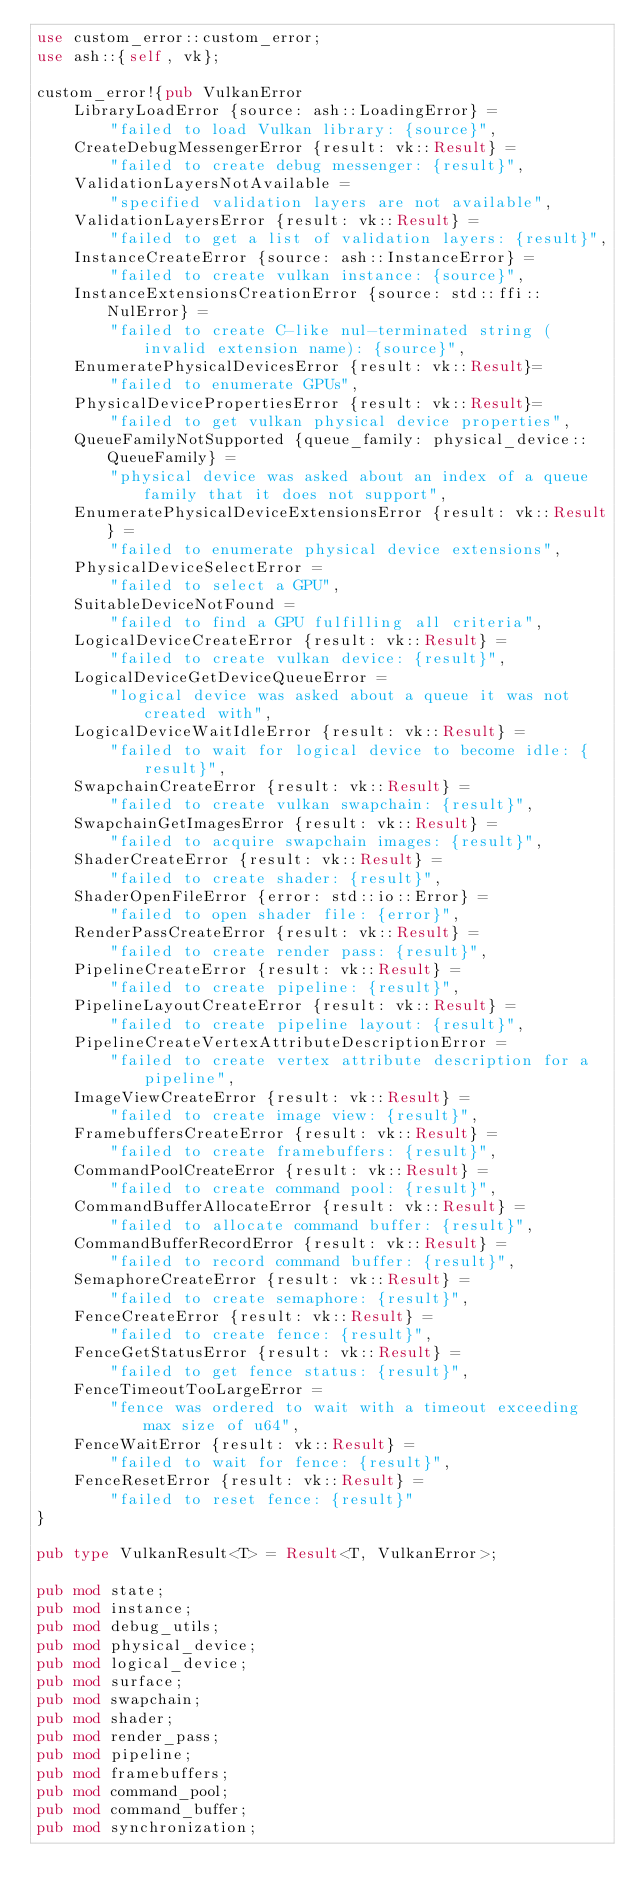<code> <loc_0><loc_0><loc_500><loc_500><_Rust_>use custom_error::custom_error;
use ash::{self, vk};

custom_error!{pub VulkanError
    LibraryLoadError {source: ash::LoadingError} =
        "failed to load Vulkan library: {source}",
    CreateDebugMessengerError {result: vk::Result} =
        "failed to create debug messenger: {result}",
    ValidationLayersNotAvailable =
        "specified validation layers are not available",
    ValidationLayersError {result: vk::Result} =
        "failed to get a list of validation layers: {result}",
    InstanceCreateError {source: ash::InstanceError} =
        "failed to create vulkan instance: {source}",
    InstanceExtensionsCreationError {source: std::ffi::NulError} =
        "failed to create C-like nul-terminated string (invalid extension name): {source}",
    EnumeratePhysicalDevicesError {result: vk::Result}=
        "failed to enumerate GPUs",
    PhysicalDevicePropertiesError {result: vk::Result}=
        "failed to get vulkan physical device properties",
    QueueFamilyNotSupported {queue_family: physical_device::QueueFamily} =
        "physical device was asked about an index of a queue family that it does not support",
    EnumeratePhysicalDeviceExtensionsError {result: vk::Result} = 
        "failed to enumerate physical device extensions",
    PhysicalDeviceSelectError =
        "failed to select a GPU",
    SuitableDeviceNotFound =
        "failed to find a GPU fulfilling all criteria",
    LogicalDeviceCreateError {result: vk::Result} =
        "failed to create vulkan device: {result}",
    LogicalDeviceGetDeviceQueueError =
        "logical device was asked about a queue it was not created with",
    LogicalDeviceWaitIdleError {result: vk::Result} =
        "failed to wait for logical device to become idle: {result}",
    SwapchainCreateError {result: vk::Result} =
        "failed to create vulkan swapchain: {result}",
    SwapchainGetImagesError {result: vk::Result} =
        "failed to acquire swapchain images: {result}",
    ShaderCreateError {result: vk::Result} =
        "failed to create shader: {result}",
    ShaderOpenFileError {error: std::io::Error} =
        "failed to open shader file: {error}",
    RenderPassCreateError {result: vk::Result} =
        "failed to create render pass: {result}",
    PipelineCreateError {result: vk::Result} =
        "failed to create pipeline: {result}",
    PipelineLayoutCreateError {result: vk::Result} =
        "failed to create pipeline layout: {result}",
    PipelineCreateVertexAttributeDescriptionError =
        "failed to create vertex attribute description for a pipeline",
    ImageViewCreateError {result: vk::Result} =
        "failed to create image view: {result}",
    FramebuffersCreateError {result: vk::Result} =
        "failed to create framebuffers: {result}",
    CommandPoolCreateError {result: vk::Result} =
        "failed to create command pool: {result}",
    CommandBufferAllocateError {result: vk::Result} =
        "failed to allocate command buffer: {result}",
    CommandBufferRecordError {result: vk::Result} =
        "failed to record command buffer: {result}",
    SemaphoreCreateError {result: vk::Result} =
        "failed to create semaphore: {result}",
    FenceCreateError {result: vk::Result} =
        "failed to create fence: {result}",
    FenceGetStatusError {result: vk::Result} =
        "failed to get fence status: {result}",
    FenceTimeoutTooLargeError =
        "fence was ordered to wait with a timeout exceeding max size of u64",
    FenceWaitError {result: vk::Result} =
        "failed to wait for fence: {result}",
    FenceResetError {result: vk::Result} =
        "failed to reset fence: {result}"
}

pub type VulkanResult<T> = Result<T, VulkanError>;

pub mod state;
pub mod instance;
pub mod debug_utils;
pub mod physical_device;
pub mod logical_device;
pub mod surface;
pub mod swapchain;
pub mod shader;
pub mod render_pass;
pub mod pipeline;
pub mod framebuffers;
pub mod command_pool;
pub mod command_buffer;
pub mod synchronization;
</code> 